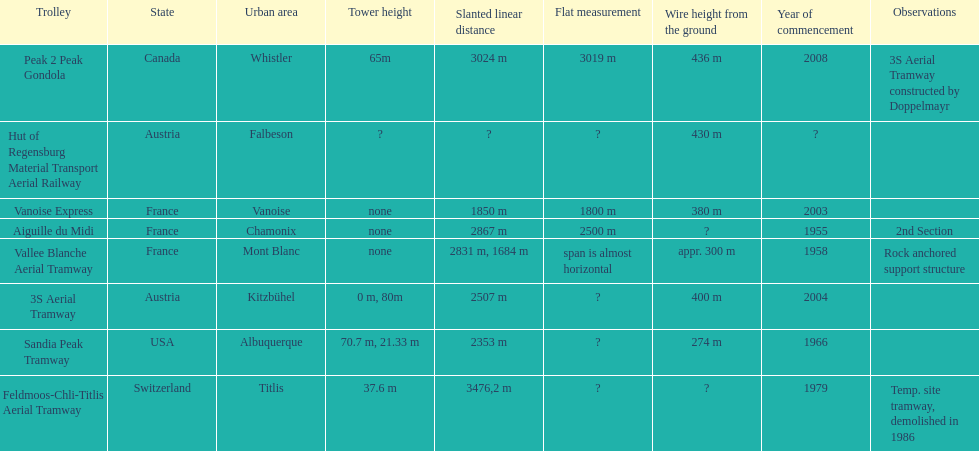How many aerial tramways are located in france? 3. 